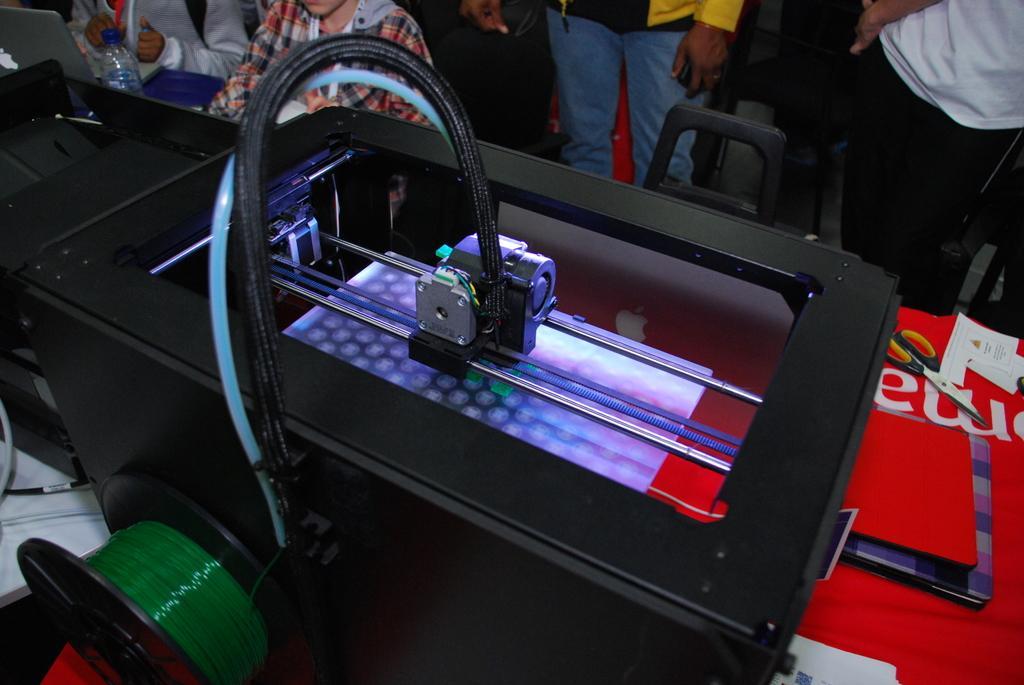How would you summarize this image in a sentence or two? Here on the table we can see scissors,laptops,papers and some electronic devices and objects. In the background there are few people,chairs and a water bottle. 